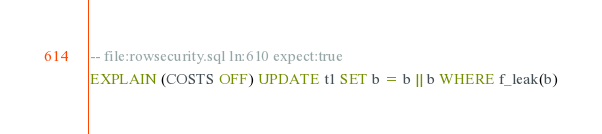<code> <loc_0><loc_0><loc_500><loc_500><_SQL_>-- file:rowsecurity.sql ln:610 expect:true
EXPLAIN (COSTS OFF) UPDATE t1 SET b = b || b WHERE f_leak(b)
</code> 